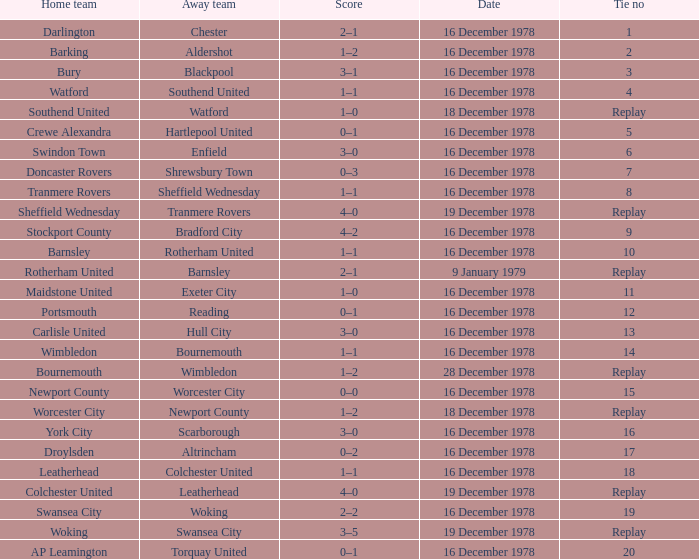Parse the table in full. {'header': ['Home team', 'Away team', 'Score', 'Date', 'Tie no'], 'rows': [['Darlington', 'Chester', '2–1', '16 December 1978', '1'], ['Barking', 'Aldershot', '1–2', '16 December 1978', '2'], ['Bury', 'Blackpool', '3–1', '16 December 1978', '3'], ['Watford', 'Southend United', '1–1', '16 December 1978', '4'], ['Southend United', 'Watford', '1–0', '18 December 1978', 'Replay'], ['Crewe Alexandra', 'Hartlepool United', '0–1', '16 December 1978', '5'], ['Swindon Town', 'Enfield', '3–0', '16 December 1978', '6'], ['Doncaster Rovers', 'Shrewsbury Town', '0–3', '16 December 1978', '7'], ['Tranmere Rovers', 'Sheffield Wednesday', '1–1', '16 December 1978', '8'], ['Sheffield Wednesday', 'Tranmere Rovers', '4–0', '19 December 1978', 'Replay'], ['Stockport County', 'Bradford City', '4–2', '16 December 1978', '9'], ['Barnsley', 'Rotherham United', '1–1', '16 December 1978', '10'], ['Rotherham United', 'Barnsley', '2–1', '9 January 1979', 'Replay'], ['Maidstone United', 'Exeter City', '1–0', '16 December 1978', '11'], ['Portsmouth', 'Reading', '0–1', '16 December 1978', '12'], ['Carlisle United', 'Hull City', '3–0', '16 December 1978', '13'], ['Wimbledon', 'Bournemouth', '1–1', '16 December 1978', '14'], ['Bournemouth', 'Wimbledon', '1–2', '28 December 1978', 'Replay'], ['Newport County', 'Worcester City', '0–0', '16 December 1978', '15'], ['Worcester City', 'Newport County', '1–2', '18 December 1978', 'Replay'], ['York City', 'Scarborough', '3–0', '16 December 1978', '16'], ['Droylsden', 'Altrincham', '0–2', '16 December 1978', '17'], ['Leatherhead', 'Colchester United', '1–1', '16 December 1978', '18'], ['Colchester United', 'Leatherhead', '4–0', '19 December 1978', 'Replay'], ['Swansea City', 'Woking', '2–2', '16 December 1978', '19'], ['Woking', 'Swansea City', '3–5', '19 December 1978', 'Replay'], ['AP Leamington', 'Torquay United', '0–1', '16 December 1978', '20']]} Waht was the away team when the home team is colchester united? Leatherhead. 